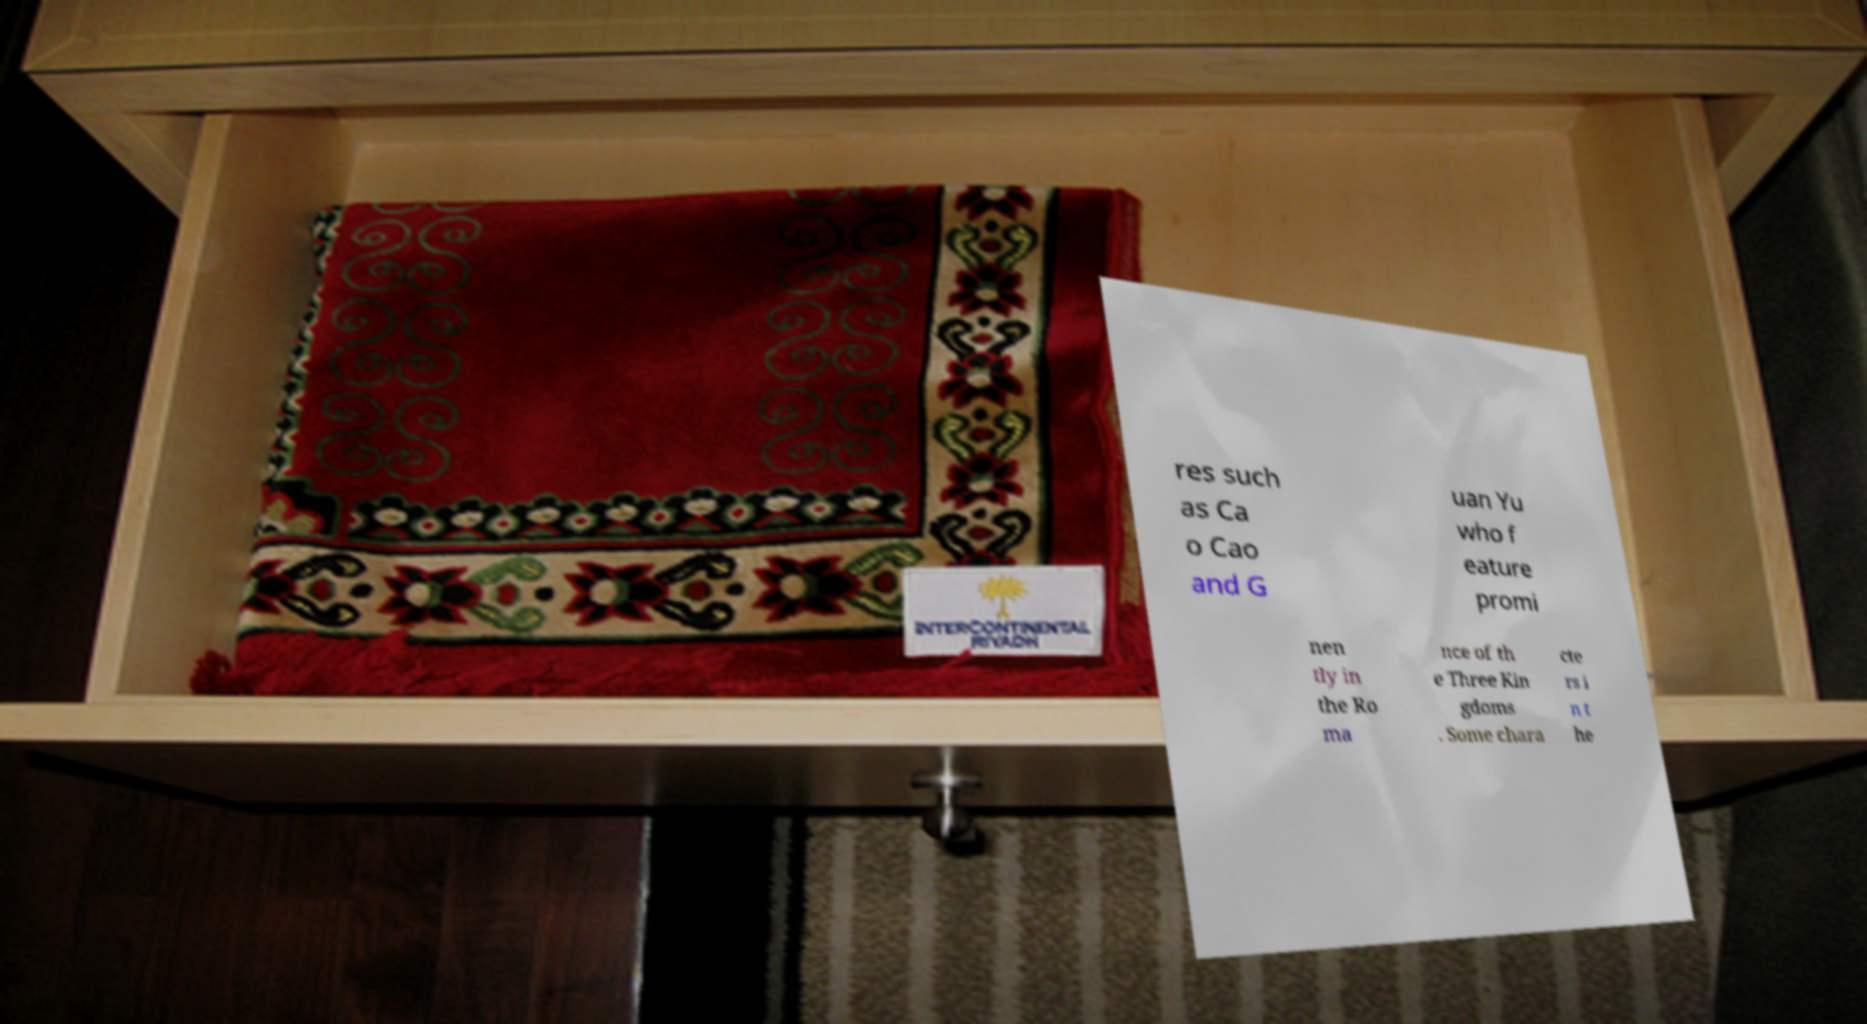I need the written content from this picture converted into text. Can you do that? res such as Ca o Cao and G uan Yu who f eature promi nen tly in the Ro ma nce of th e Three Kin gdoms . Some chara cte rs i n t he 